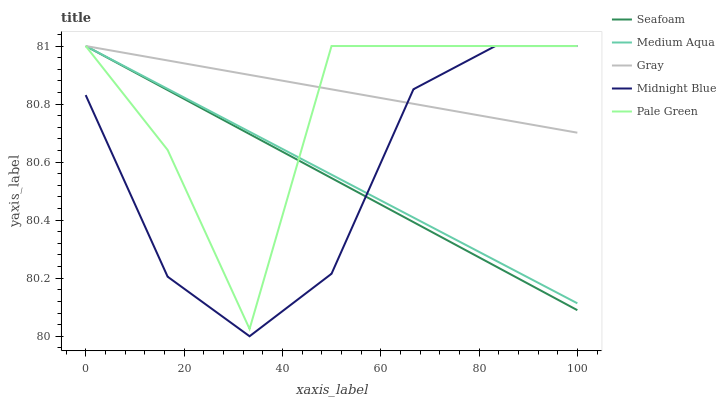Does Midnight Blue have the minimum area under the curve?
Answer yes or no. Yes. Does Gray have the maximum area under the curve?
Answer yes or no. Yes. Does Pale Green have the minimum area under the curve?
Answer yes or no. No. Does Pale Green have the maximum area under the curve?
Answer yes or no. No. Is Gray the smoothest?
Answer yes or no. Yes. Is Pale Green the roughest?
Answer yes or no. Yes. Is Medium Aqua the smoothest?
Answer yes or no. No. Is Medium Aqua the roughest?
Answer yes or no. No. Does Midnight Blue have the lowest value?
Answer yes or no. Yes. Does Pale Green have the lowest value?
Answer yes or no. No. Does Midnight Blue have the highest value?
Answer yes or no. Yes. Does Seafoam intersect Midnight Blue?
Answer yes or no. Yes. Is Seafoam less than Midnight Blue?
Answer yes or no. No. Is Seafoam greater than Midnight Blue?
Answer yes or no. No. 